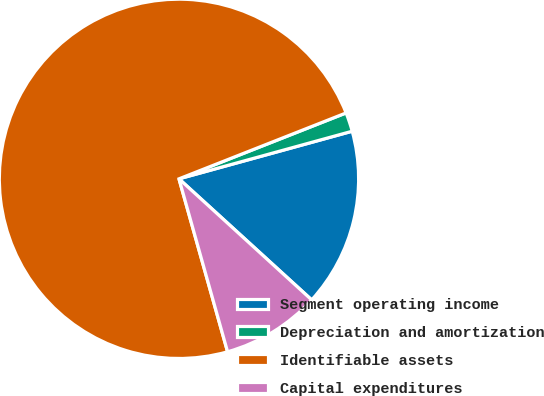Convert chart to OTSL. <chart><loc_0><loc_0><loc_500><loc_500><pie_chart><fcel>Segment operating income<fcel>Depreciation and amortization<fcel>Identifiable assets<fcel>Capital expenditures<nl><fcel>16.04%<fcel>1.71%<fcel>73.38%<fcel>8.87%<nl></chart> 